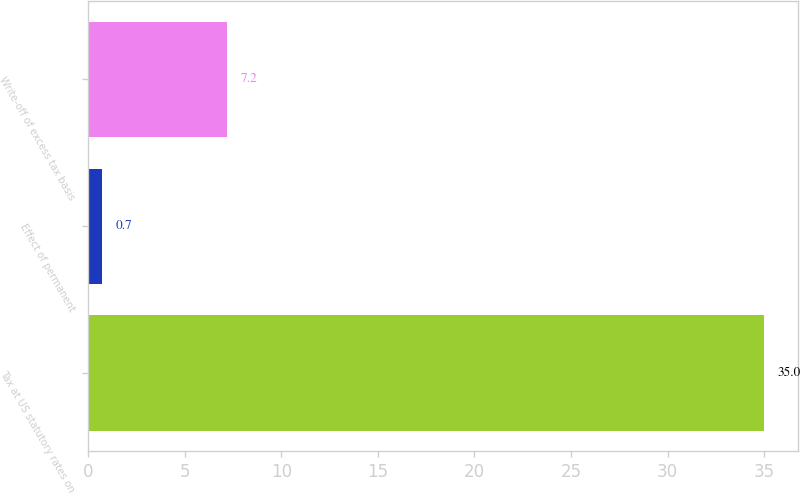Convert chart to OTSL. <chart><loc_0><loc_0><loc_500><loc_500><bar_chart><fcel>Tax at US statutory rates on<fcel>Effect of permanent<fcel>Write-off of excess tax basis<nl><fcel>35<fcel>0.7<fcel>7.2<nl></chart> 